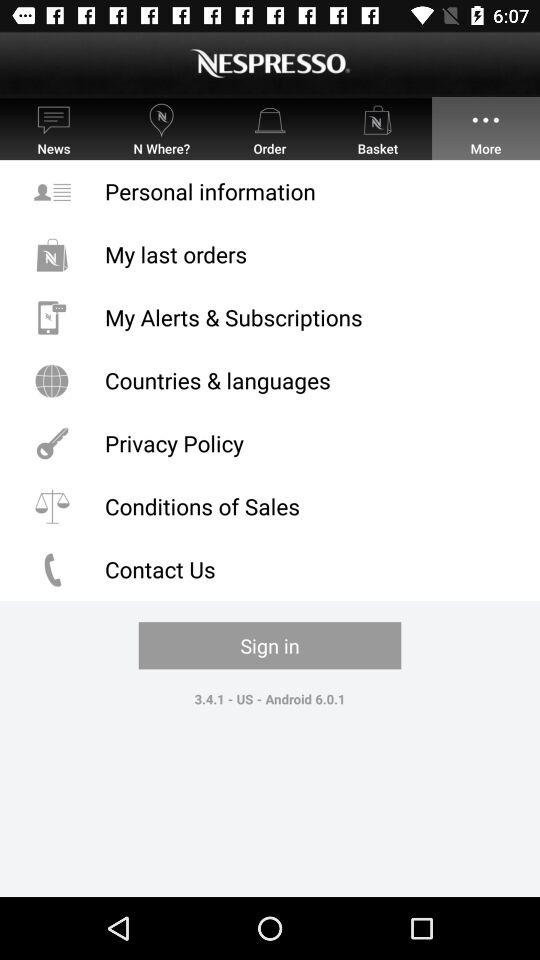What is the version of the app? The version of the app is 3.4.1. 